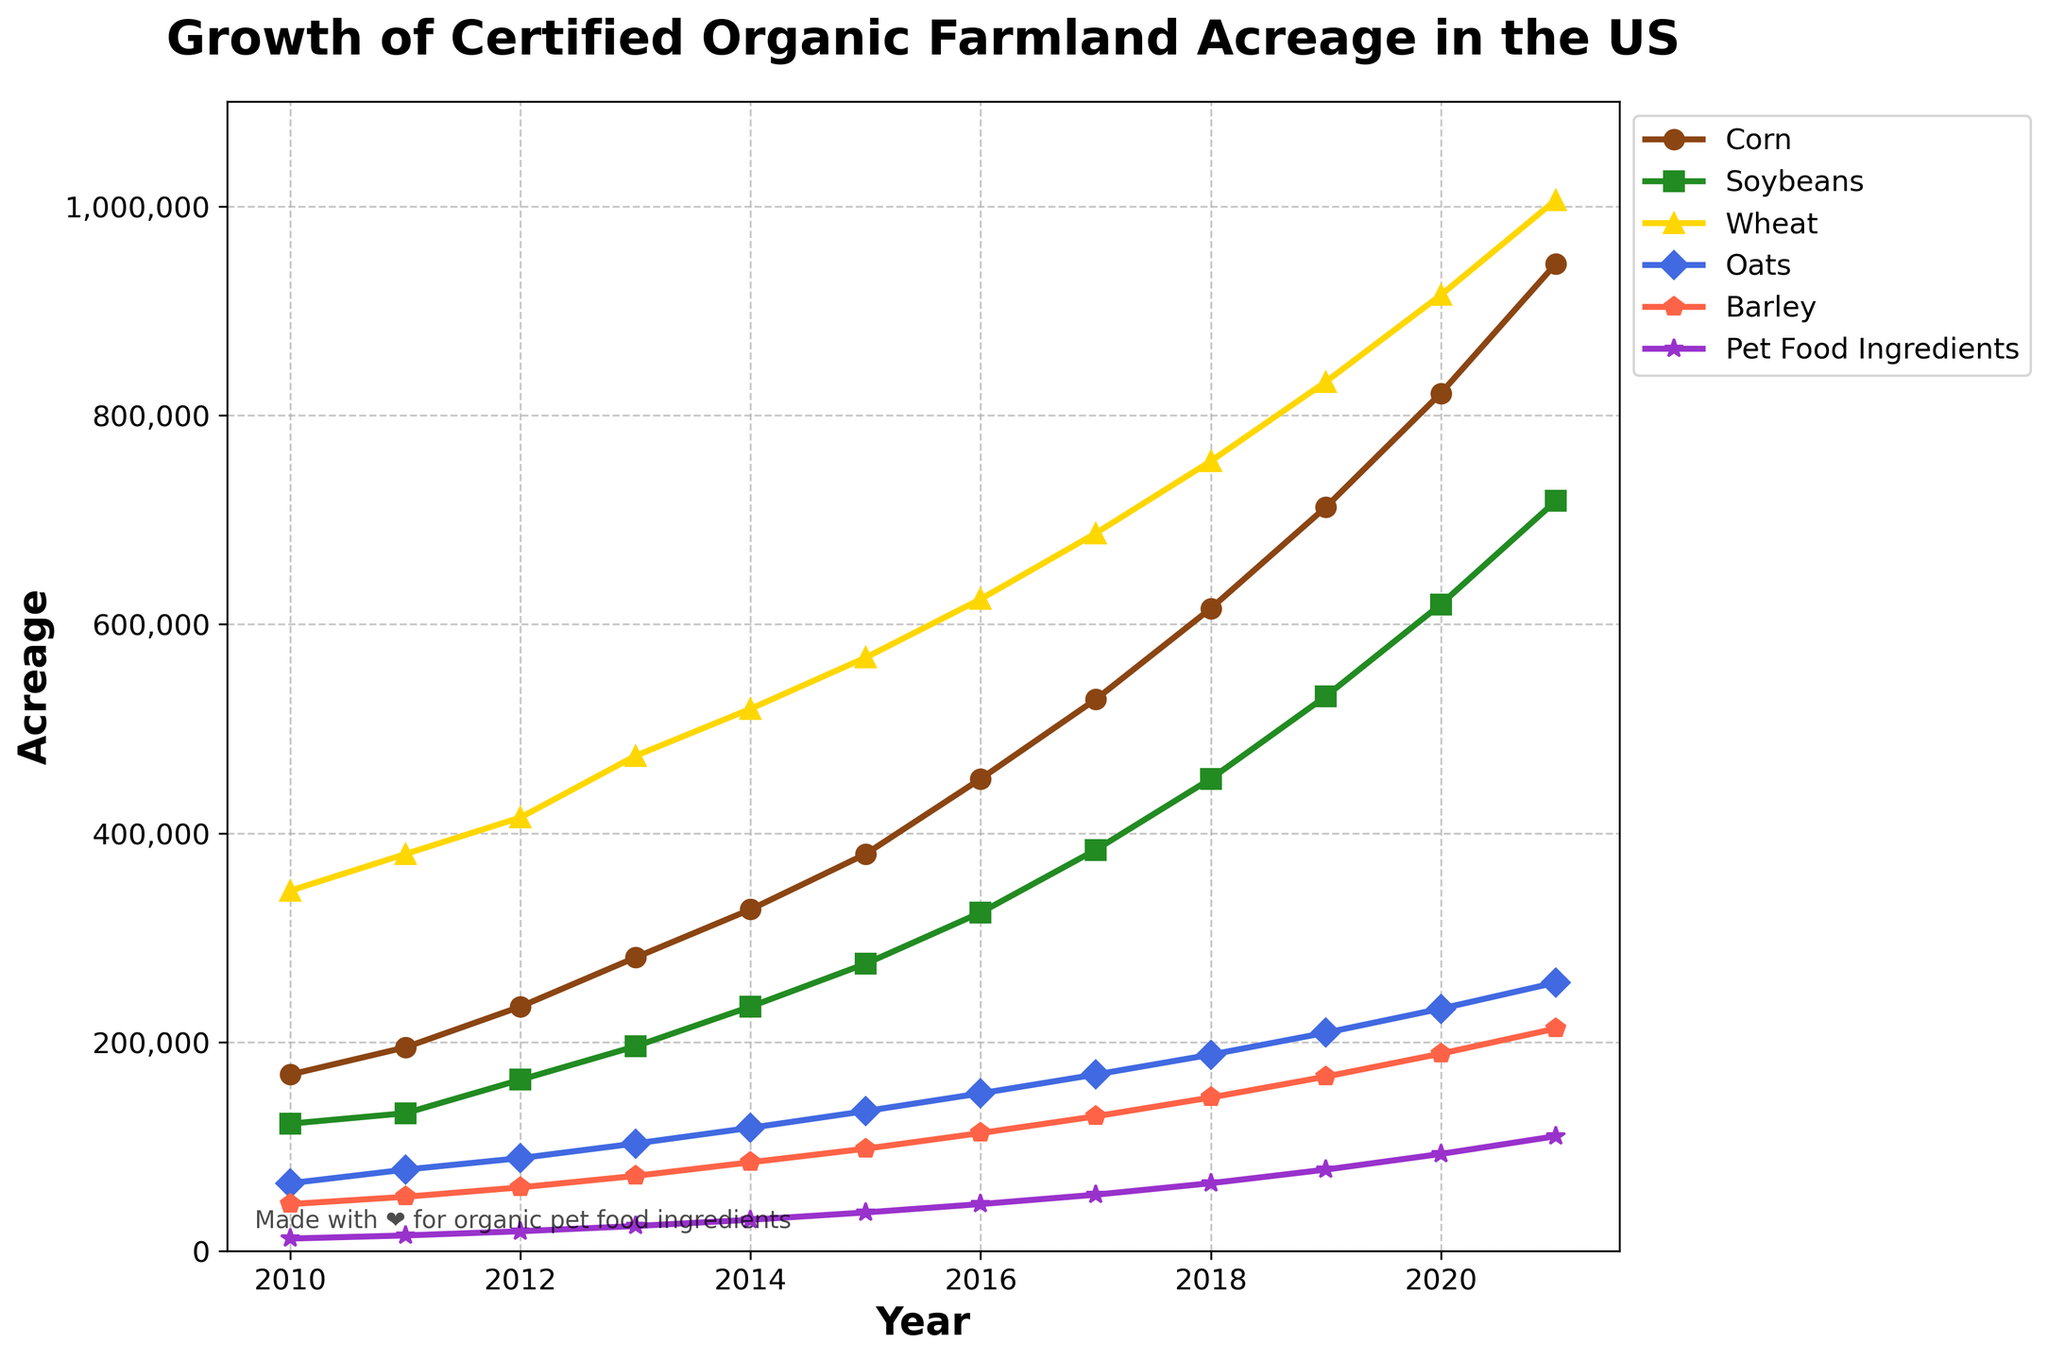What crop had the highest acreage growth from 2010 to 2021? From 2010 to 2021, examine the line chart to see which crop’s acreage increased the most over these years. Wheat's acreage increases from 345,000 in 2010 to 1,006,000 in 2021, showing the highest growth.
Answer: Wheat Compare the acreage of soybeans in 2015 and 2020. Was there an increase or a decrease? Look at soybeans in 2015 (275,000 acres) and 2020 (619,000 acres). By comparing these numbers, it's clear that there has been an increase.
Answer: Increase What is the total acreage for pet food ingredients in 2018 and 2019 combined? To find the combined acreage, add the pet food ingredients values for 2018 (65,000) and 2019 (78,000). 65,000 + 78,000 = 143,000.
Answer: 143,000 By how much did the acreage of corn increase from 2011 to 2012? Examine the values for corn in 2011 (195,000 acres) and 2012 (234,000 acres). The increase is 234,000 - 195,000 = 39,000 acres.
Answer: 39,000 acres Which crop shows a steady increasing trend in acreage over the years? Look at the lines on the chart. All lines show a general increasing trend, but wheat and corn exhibit the smoothest steady rise year by year without significant dips or variations.
Answer: Wheat and Corn What is the difference in organic farmland acreage between oats and barley in 2021? Compare the values for oats (257,000 acres) and barley (213,000 acres) in 2021. The difference is 257,000 - 213,000 = 44,000 acres.
Answer: 44,000 acres Which year did soybeans surpass 300,000 acres for the first time? Check the line for soybeans. The value first surpasses 300,000 acres in 2016 (324,000 acres).
Answer: 2016 In which year did pet food ingredients surpass 50,000 acres? Look at the pet food ingredients line. It first surpasses 50,000 acres in 2017 (54,000 acres).
Answer: 2017 Did any crop maintain the same acreage for two consecutive years? View the data points for each line. No crop shows the same acreage for two consecutive years; each year shows changes.
Answer: No What is the visual color used for the line representing oats? Look at the color-coding of the lines in the chart. The line for oats is represented in blue.
Answer: Blue 